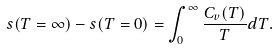Convert formula to latex. <formula><loc_0><loc_0><loc_500><loc_500>s ( T = \infty ) - s ( T = 0 ) = \int _ { 0 } ^ { \infty } \frac { C _ { v } ( T ) } { T } d T .</formula> 